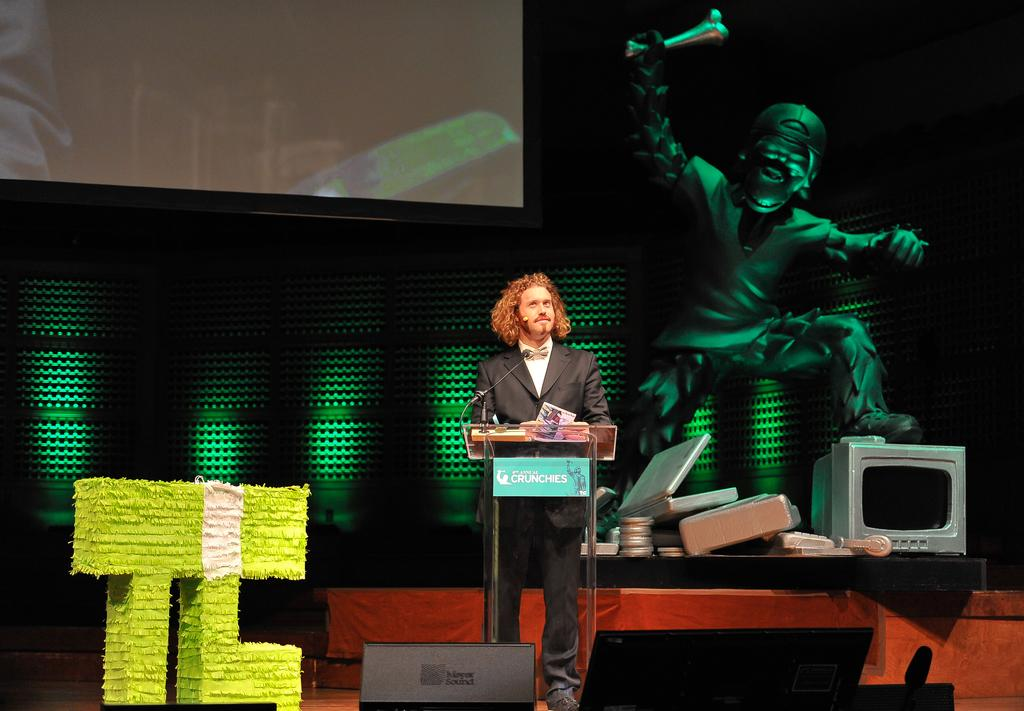Provide a one-sentence caption for the provided image. TJ Miller is on stage behind a podium reading "Crunchies". 